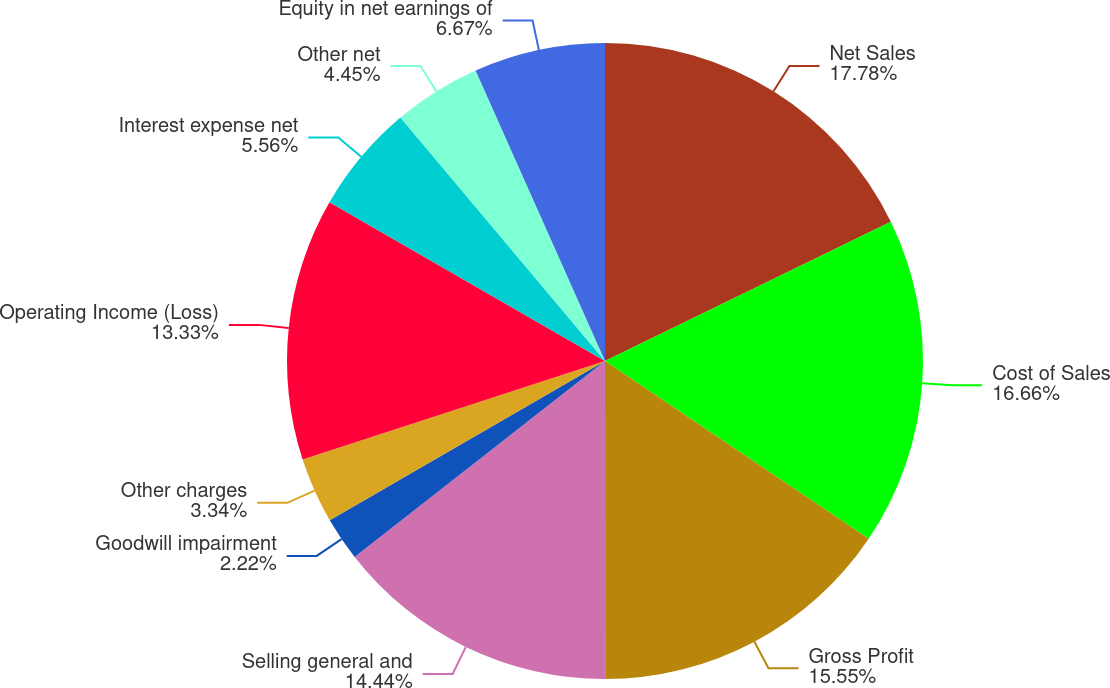<chart> <loc_0><loc_0><loc_500><loc_500><pie_chart><fcel>Net Sales<fcel>Cost of Sales<fcel>Gross Profit<fcel>Selling general and<fcel>Goodwill impairment<fcel>Other charges<fcel>Operating Income (Loss)<fcel>Interest expense net<fcel>Other net<fcel>Equity in net earnings of<nl><fcel>17.78%<fcel>16.66%<fcel>15.55%<fcel>14.44%<fcel>2.22%<fcel>3.34%<fcel>13.33%<fcel>5.56%<fcel>4.45%<fcel>6.67%<nl></chart> 